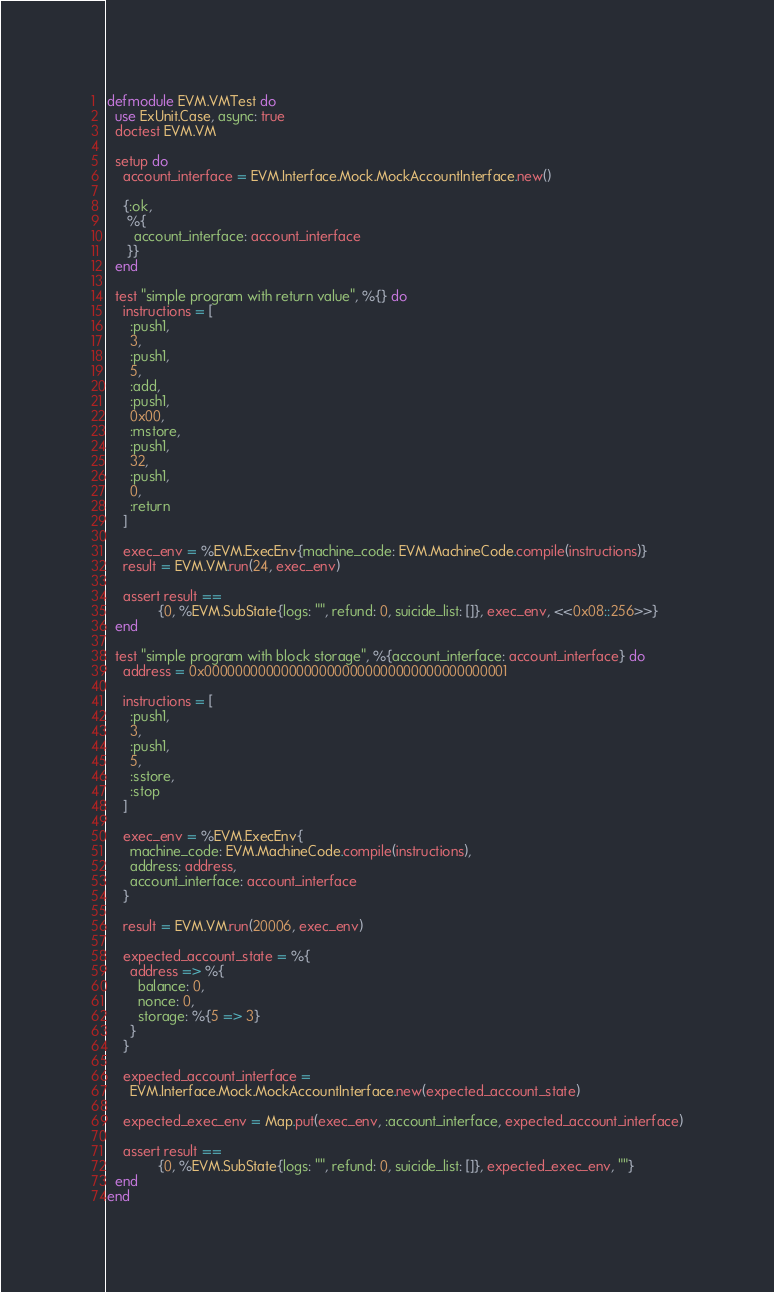Convert code to text. <code><loc_0><loc_0><loc_500><loc_500><_Elixir_>defmodule EVM.VMTest do
  use ExUnit.Case, async: true
  doctest EVM.VM

  setup do
    account_interface = EVM.Interface.Mock.MockAccountInterface.new()

    {:ok,
     %{
       account_interface: account_interface
     }}
  end

  test "simple program with return value", %{} do
    instructions = [
      :push1,
      3,
      :push1,
      5,
      :add,
      :push1,
      0x00,
      :mstore,
      :push1,
      32,
      :push1,
      0,
      :return
    ]

    exec_env = %EVM.ExecEnv{machine_code: EVM.MachineCode.compile(instructions)}
    result = EVM.VM.run(24, exec_env)

    assert result ==
             {0, %EVM.SubState{logs: "", refund: 0, suicide_list: []}, exec_env, <<0x08::256>>}
  end

  test "simple program with block storage", %{account_interface: account_interface} do
    address = 0x0000000000000000000000000000000000000001

    instructions = [
      :push1,
      3,
      :push1,
      5,
      :sstore,
      :stop
    ]

    exec_env = %EVM.ExecEnv{
      machine_code: EVM.MachineCode.compile(instructions),
      address: address,
      account_interface: account_interface
    }

    result = EVM.VM.run(20006, exec_env)

    expected_account_state = %{
      address => %{
        balance: 0,
        nonce: 0,
        storage: %{5 => 3}
      }
    }

    expected_account_interface =
      EVM.Interface.Mock.MockAccountInterface.new(expected_account_state)

    expected_exec_env = Map.put(exec_env, :account_interface, expected_account_interface)

    assert result ==
             {0, %EVM.SubState{logs: "", refund: 0, suicide_list: []}, expected_exec_env, ""}
  end
end
</code> 